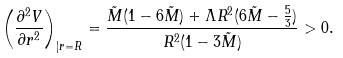<formula> <loc_0><loc_0><loc_500><loc_500>\left ( \frac { \partial ^ { 2 } V } { \partial r ^ { 2 } } \right ) _ { | r = R } = \frac { \tilde { M } ( 1 - 6 \tilde { M } ) + \Lambda R ^ { 2 } ( 6 \tilde { M } - \frac { 5 } { 3 } ) } { R ^ { 2 } ( 1 - 3 \tilde { M } ) } > 0 .</formula> 